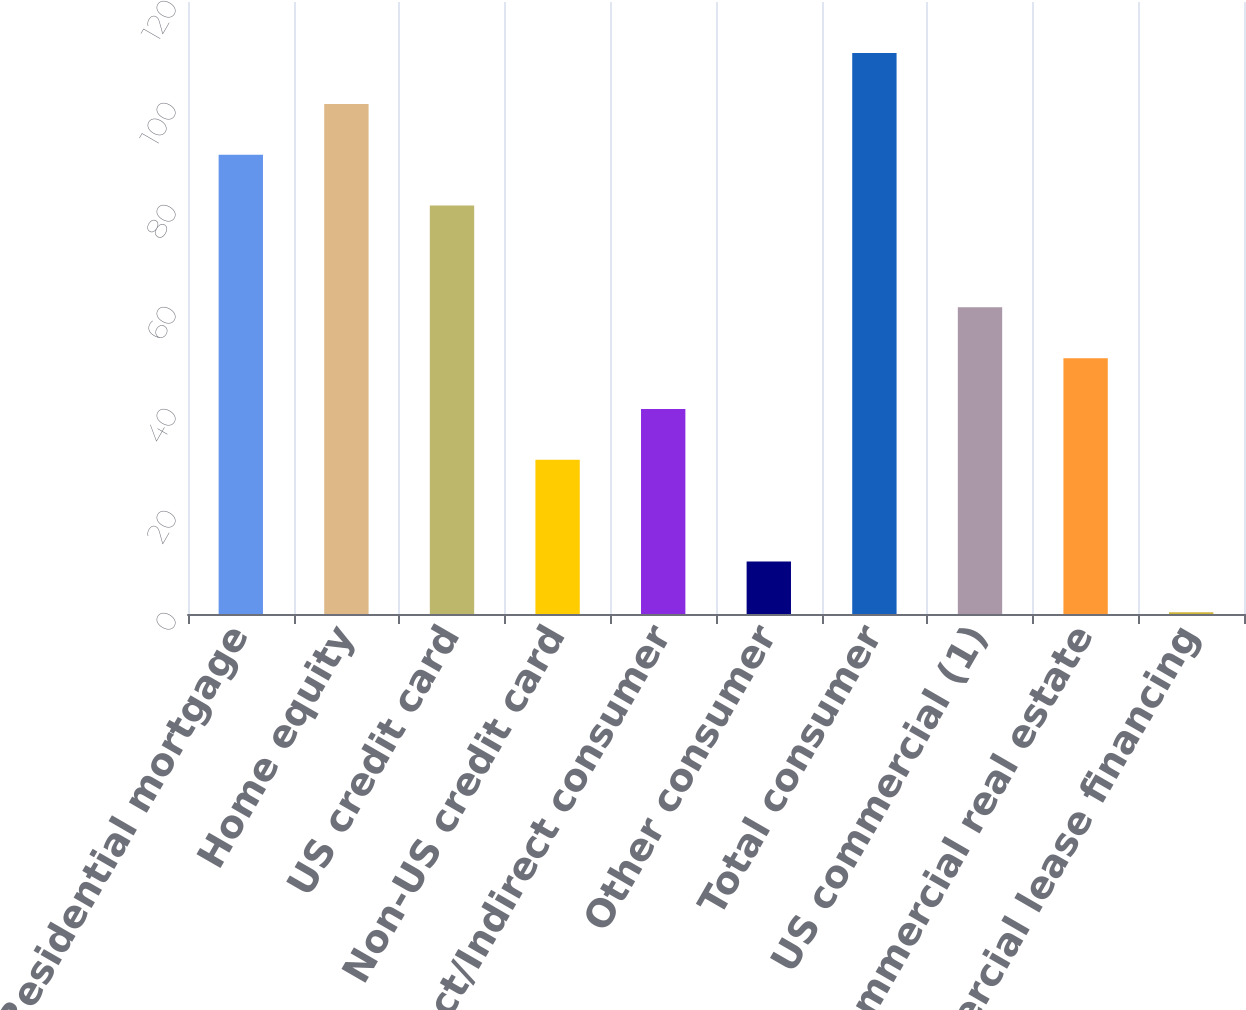<chart> <loc_0><loc_0><loc_500><loc_500><bar_chart><fcel>Residential mortgage<fcel>Home equity<fcel>US credit card<fcel>Non-US credit card<fcel>Direct/Indirect consumer<fcel>Other consumer<fcel>Total consumer<fcel>US commercial (1)<fcel>Commercial real estate<fcel>Commercial lease financing<nl><fcel>90.05<fcel>100.02<fcel>80.08<fcel>30.23<fcel>40.2<fcel>10.29<fcel>109.99<fcel>60.14<fcel>50.17<fcel>0.32<nl></chart> 